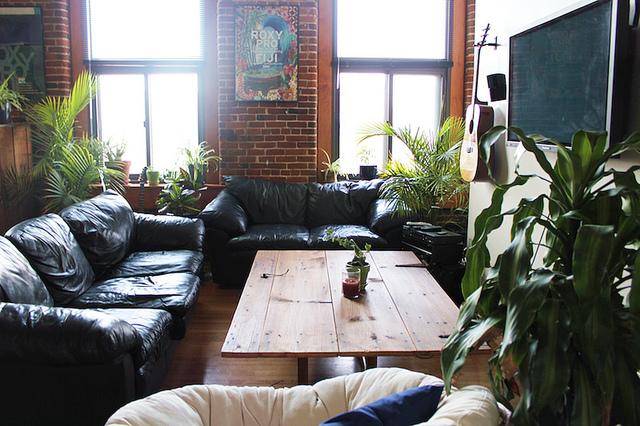Are the couches made of cloth?
Give a very brief answer. No. Is there a TV hanging on the wall?
Answer briefly. Yes. Does the painting have one main color?
Keep it brief. No. 